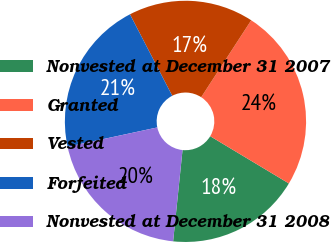Convert chart. <chart><loc_0><loc_0><loc_500><loc_500><pie_chart><fcel>Nonvested at December 31 2007<fcel>Granted<fcel>Vested<fcel>Forfeited<fcel>Nonvested at December 31 2008<nl><fcel>18.03%<fcel>24.43%<fcel>16.79%<fcel>20.76%<fcel>19.99%<nl></chart> 